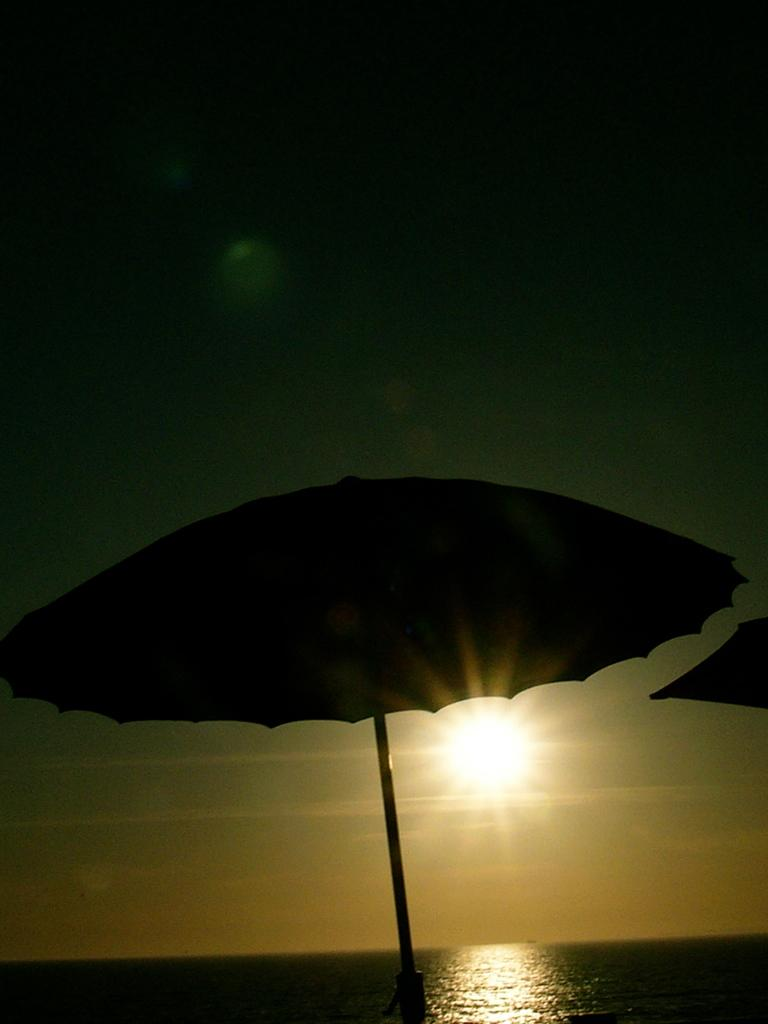What objects are present in the image that provide shade? There are parasols in the image. What is the primary element in which the parasols are situated? The parasols are situated in water, which is visible in the image. What can be seen in the sky in the image? The sky is visible in the image, and the sun is observable. What type of bait is being used to catch the rat in the image? There is no rat or bait present in the image; it features parasols in water with the sky and sun visible. 